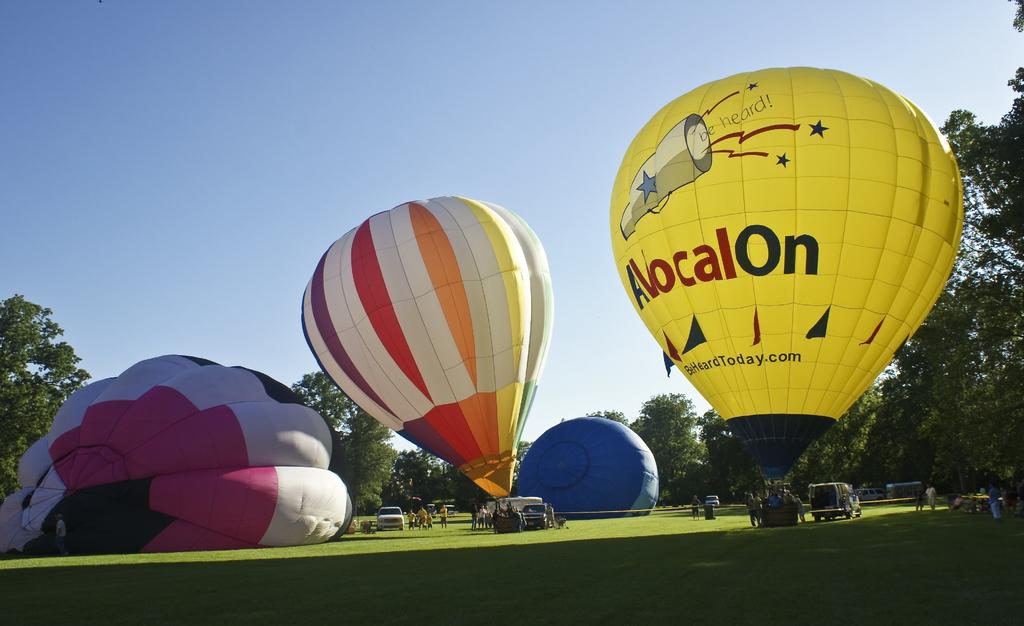What type of vehicles can be seen in the image? There are cars in the image. What kind of living organisms are present in the image? There are people, trees, and plants in the image. What is the ground covered with in the image? There is grass on the ground in the image. What are the air balloons doing in the image? The air balloons are present in the image, but their specific activity is not mentioned. What type of cloud can be seen in the image? There is no cloud present in the image. What sound does the force make in the image? There is no force or sound mentioned in the image. 